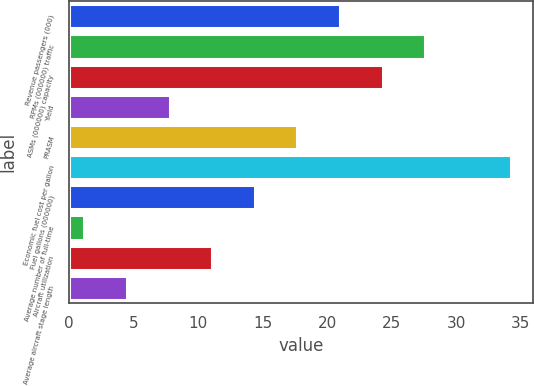<chart> <loc_0><loc_0><loc_500><loc_500><bar_chart><fcel>Revenue passengers (000)<fcel>RPMs (000000) traffic<fcel>ASMs (000000) capacity<fcel>Yield<fcel>PRASM<fcel>Economic fuel cost per gallon<fcel>Fuel gallons (000000)<fcel>Average number of full-time<fcel>Aircraft utilization<fcel>Average aircraft stage length<nl><fcel>21<fcel>27.6<fcel>24.3<fcel>7.8<fcel>17.7<fcel>34.2<fcel>14.4<fcel>1.2<fcel>11.1<fcel>4.5<nl></chart> 